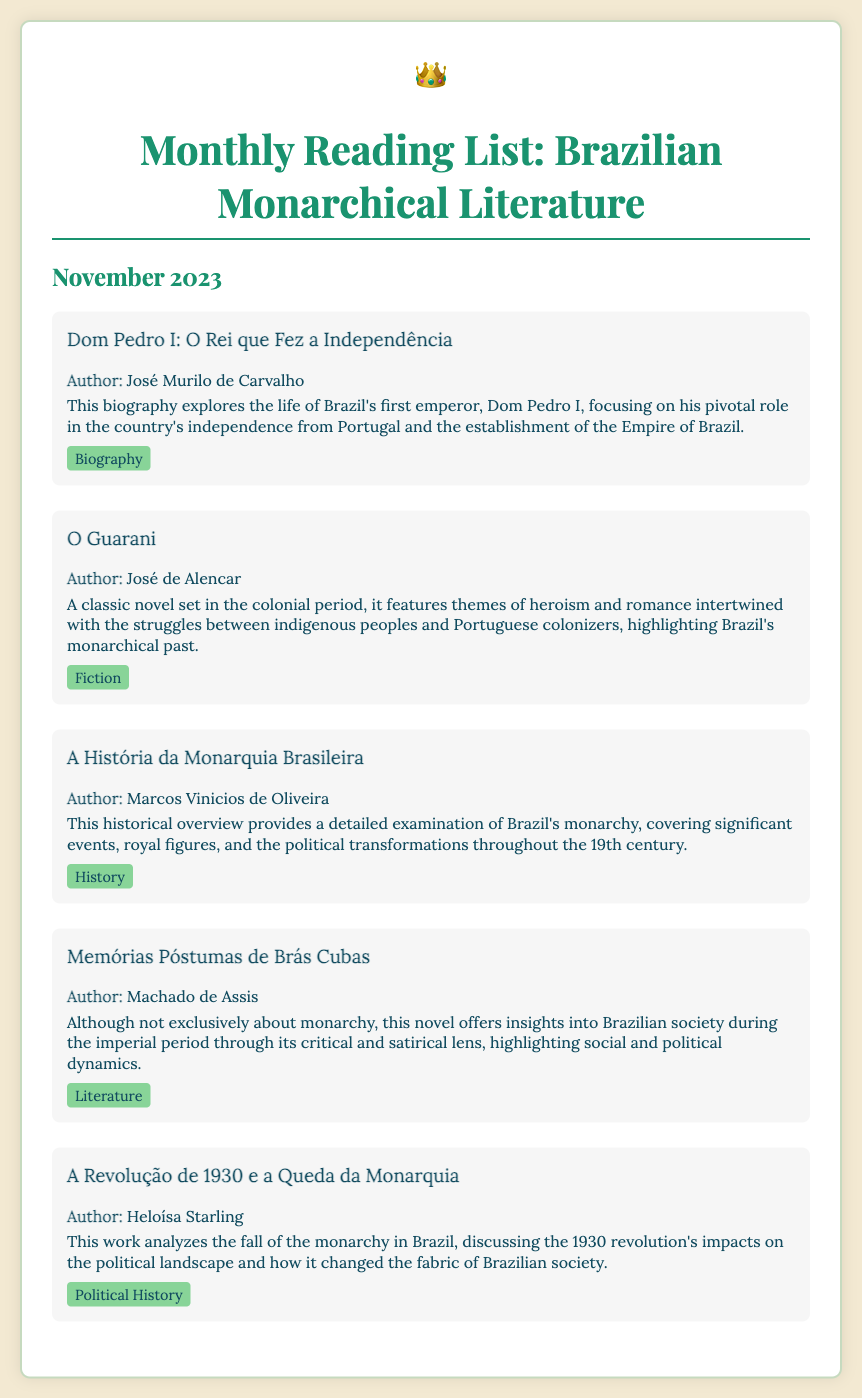What is the title of the reading list? The title at the top of the document indicates the main subject of the list.
Answer: Monthly Reading List: Brazilian Monarchical Literature Who is the author of "Dom Pedro I: O Rei que Fez a Independência"? The document provides the author's name next to each book title.
Answer: José Murilo de Carvalho What category does "O Guarani" fall under? Each book is associated with a specific genre or category indicated in the document.
Answer: Fiction Which book discusses the fall of the monarchy in Brazil? The title of the book addresses its focus on the historical event related to the monarchy.
Answer: A Revolução de 1930 e a Queda da Monarquia What is the name of the author of "Memórias Póstumas de Brás Cubas"? The document states the author adjacent to each book, particularly for this one.
Answer: Machado de Assis How many books are listed in the document? Counting the entries of the books presented will give the total amount listed.
Answer: Five What is the focus period of "A História da Monarquia Brasileira"? The description mentions the time span covered in the book, which refers to historical context.
Answer: 19th century Which book offers a critical view of Brazilian society during the imperial period? The text highlights that this book provides insights into societal norms of the period.
Answer: Memórias Póstumas de Brás Cubas Who wrote "A História da Monarquia Brasileira"? The book’s authorship is explicitly mentioned within its entry in the document.
Answer: Marcos Vinicios de Oliveira 